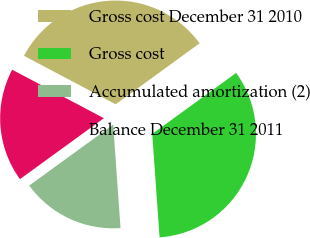<chart> <loc_0><loc_0><loc_500><loc_500><pie_chart><fcel>Gross cost December 31 2010<fcel>Gross cost<fcel>Accumulated amortization (2)<fcel>Balance December 31 2011<nl><fcel>32.26%<fcel>33.87%<fcel>16.13%<fcel>17.74%<nl></chart> 